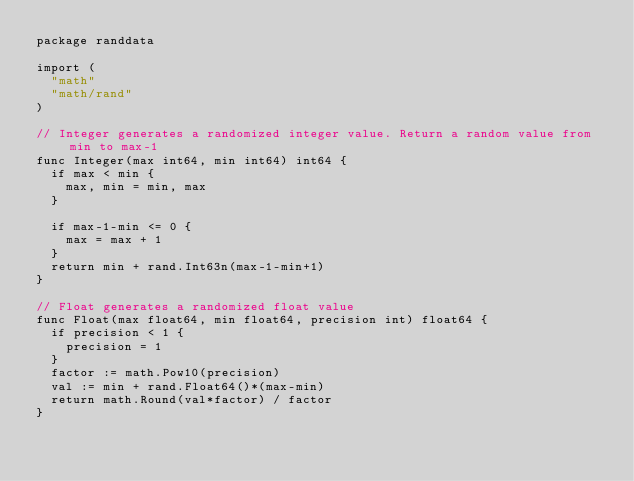Convert code to text. <code><loc_0><loc_0><loc_500><loc_500><_Go_>package randdata

import (
	"math"
	"math/rand"
)

// Integer generates a randomized integer value. Return a random value from min to max-1
func Integer(max int64, min int64) int64 {
	if max < min {
		max, min = min, max
	}

	if max-1-min <= 0 {
		max = max + 1
	}
	return min + rand.Int63n(max-1-min+1)
}

// Float generates a randomized float value
func Float(max float64, min float64, precision int) float64 {
	if precision < 1 {
		precision = 1
	}
	factor := math.Pow10(precision)
	val := min + rand.Float64()*(max-min)
	return math.Round(val*factor) / factor
}
</code> 